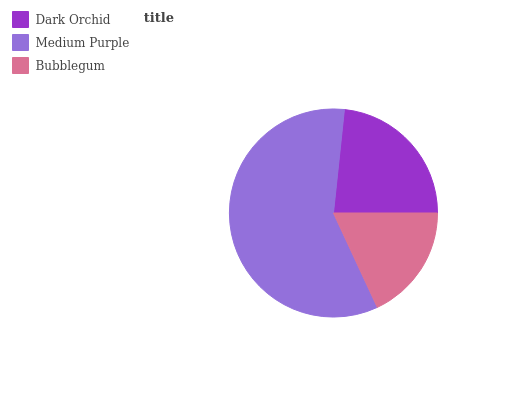Is Bubblegum the minimum?
Answer yes or no. Yes. Is Medium Purple the maximum?
Answer yes or no. Yes. Is Medium Purple the minimum?
Answer yes or no. No. Is Bubblegum the maximum?
Answer yes or no. No. Is Medium Purple greater than Bubblegum?
Answer yes or no. Yes. Is Bubblegum less than Medium Purple?
Answer yes or no. Yes. Is Bubblegum greater than Medium Purple?
Answer yes or no. No. Is Medium Purple less than Bubblegum?
Answer yes or no. No. Is Dark Orchid the high median?
Answer yes or no. Yes. Is Dark Orchid the low median?
Answer yes or no. Yes. Is Medium Purple the high median?
Answer yes or no. No. Is Medium Purple the low median?
Answer yes or no. No. 